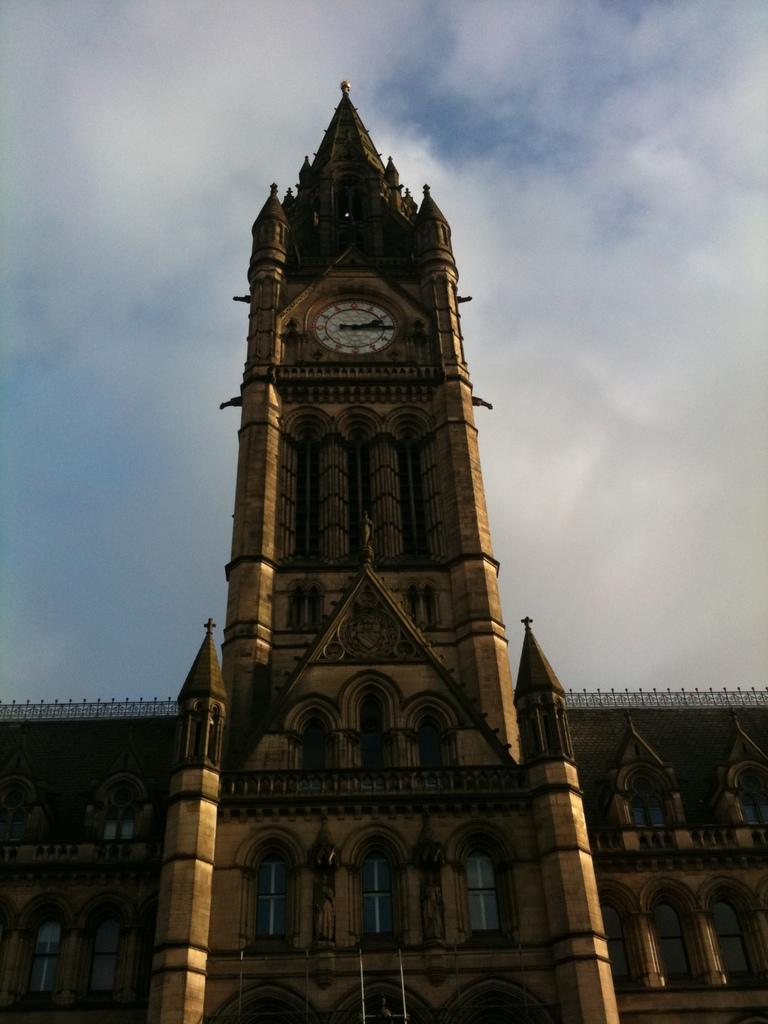Please provide a concise description of this image. In this image we can see clock tower, building, windows, pillars and sky with clouds. 